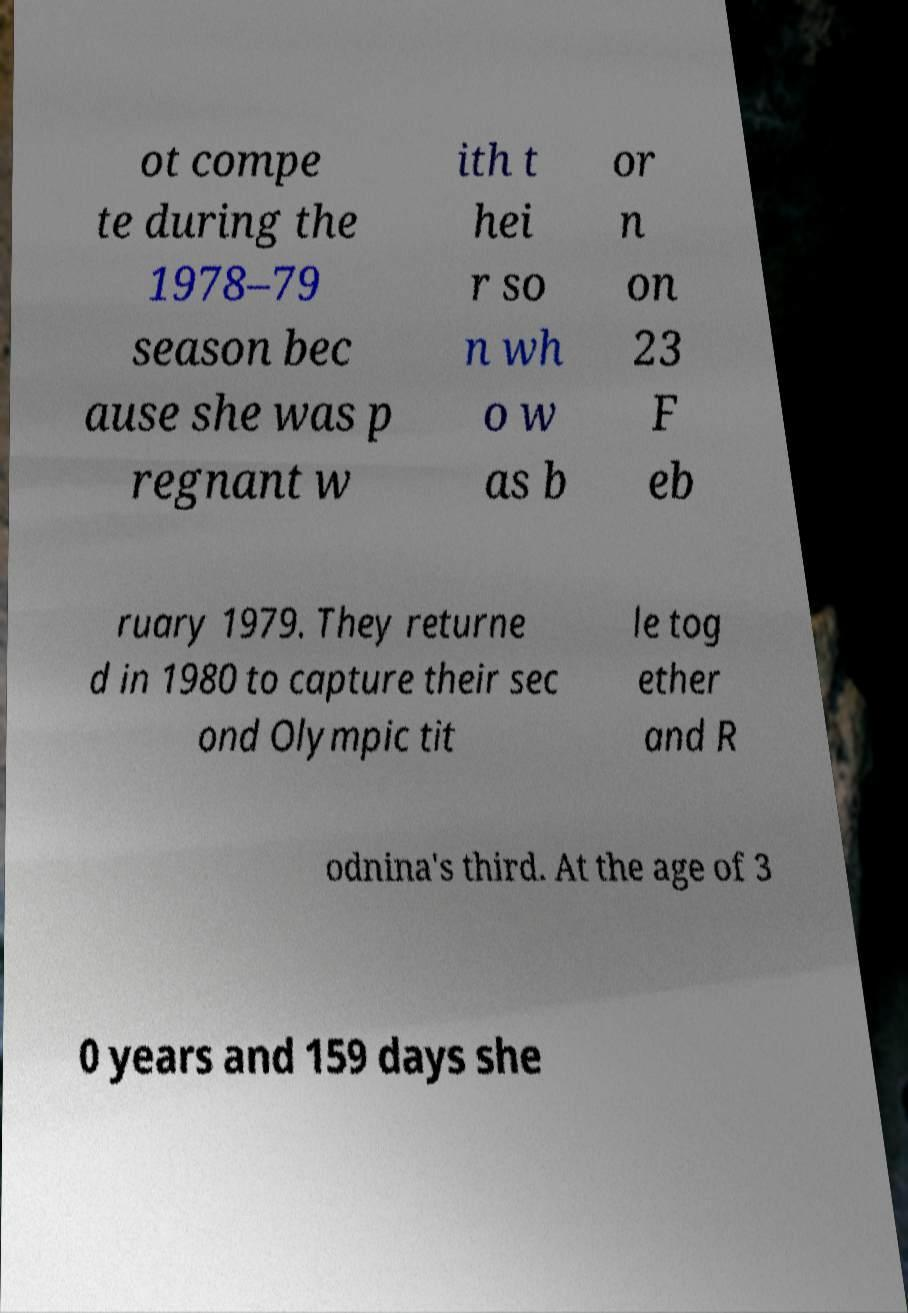Could you extract and type out the text from this image? ot compe te during the 1978–79 season bec ause she was p regnant w ith t hei r so n wh o w as b or n on 23 F eb ruary 1979. They returne d in 1980 to capture their sec ond Olympic tit le tog ether and R odnina's third. At the age of 3 0 years and 159 days she 